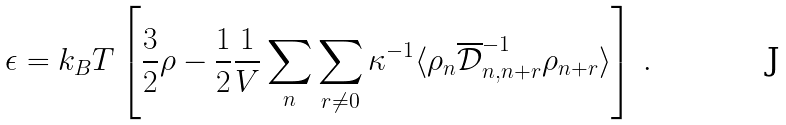Convert formula to latex. <formula><loc_0><loc_0><loc_500><loc_500>\epsilon = k _ { B } T \left [ \frac { 3 } { 2 } \rho - \frac { 1 } { 2 } \frac { 1 } { V } \sum _ { n } \sum _ { r \neq 0 } \kappa ^ { - 1 } \langle \rho _ { n } \overline { \mathcal { D } } ^ { - 1 } _ { n , n + r } \rho _ { n + r } \rangle \right ] \, .</formula> 